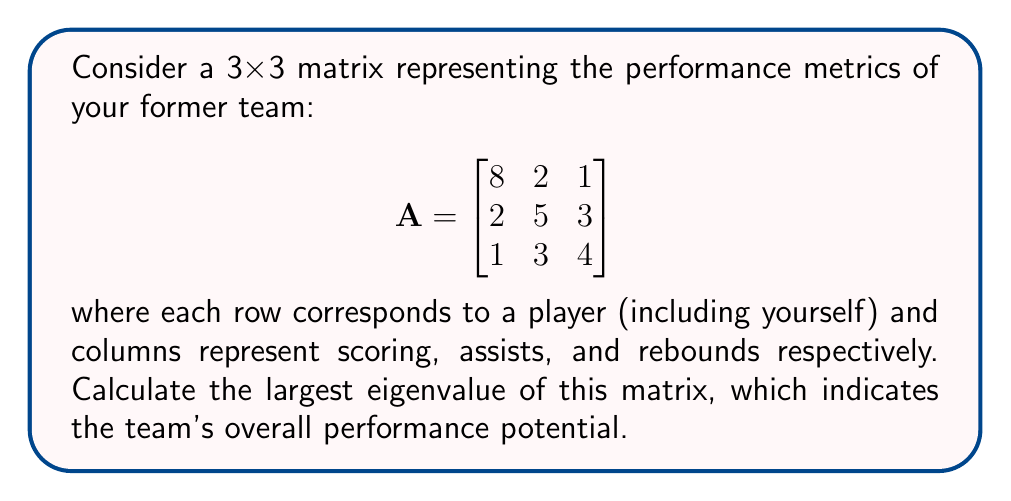Show me your answer to this math problem. To find the eigenvalues, we need to solve the characteristic equation:

1) First, calculate $det(A - \lambda I)$:

   $$det\begin{bmatrix}
   8-\lambda & 2 & 1 \\
   2 & 5-\lambda & 3 \\
   1 & 3 & 4-\lambda
   \end{bmatrix} = 0$$

2) Expand the determinant:
   
   $(8-\lambda)[(5-\lambda)(4-\lambda) - 9] - 2[2(4-\lambda) - 3] + 1[6 - 2(5-\lambda)] = 0$

3) Simplify:
   
   $(8-\lambda)(\lambda^2 - 9\lambda + 11) - 2(8-3\lambda) + 1(2\lambda - 4) = 0$
   
   $\lambda^3 - 17\lambda^2 + 88\lambda - 140 = 0$

4) This is a cubic equation. We can use the rational root theorem to find one root, then factor.

5) Potential rational roots are factors of 140: ±1, ±2, ±4, ±5, ±7, ±10, ±14, ±20, ±28, ±35, ±70, ±140

6) Testing these, we find that $\lambda = 10$ is a root.

7) Factoring out $(λ - 10)$:
   
   $(\lambda - 10)(\lambda^2 - 7\lambda + 14) = 0$

8) Using the quadratic formula for $\lambda^2 - 7\lambda + 14 = 0$:
   
   $\lambda = \frac{7 \pm \sqrt{49 - 56}}{2} = \frac{7 \pm \sqrt{-7}}{2}$

9) The eigenvalues are $\lambda_1 = 10$, $\lambda_2 = \frac{7 + i\sqrt{7}}{2}$, $\lambda_3 = \frac{7 - i\sqrt{7}}{2}$

10) The largest eigenvalue is $\lambda_1 = 10$.
Answer: 10 